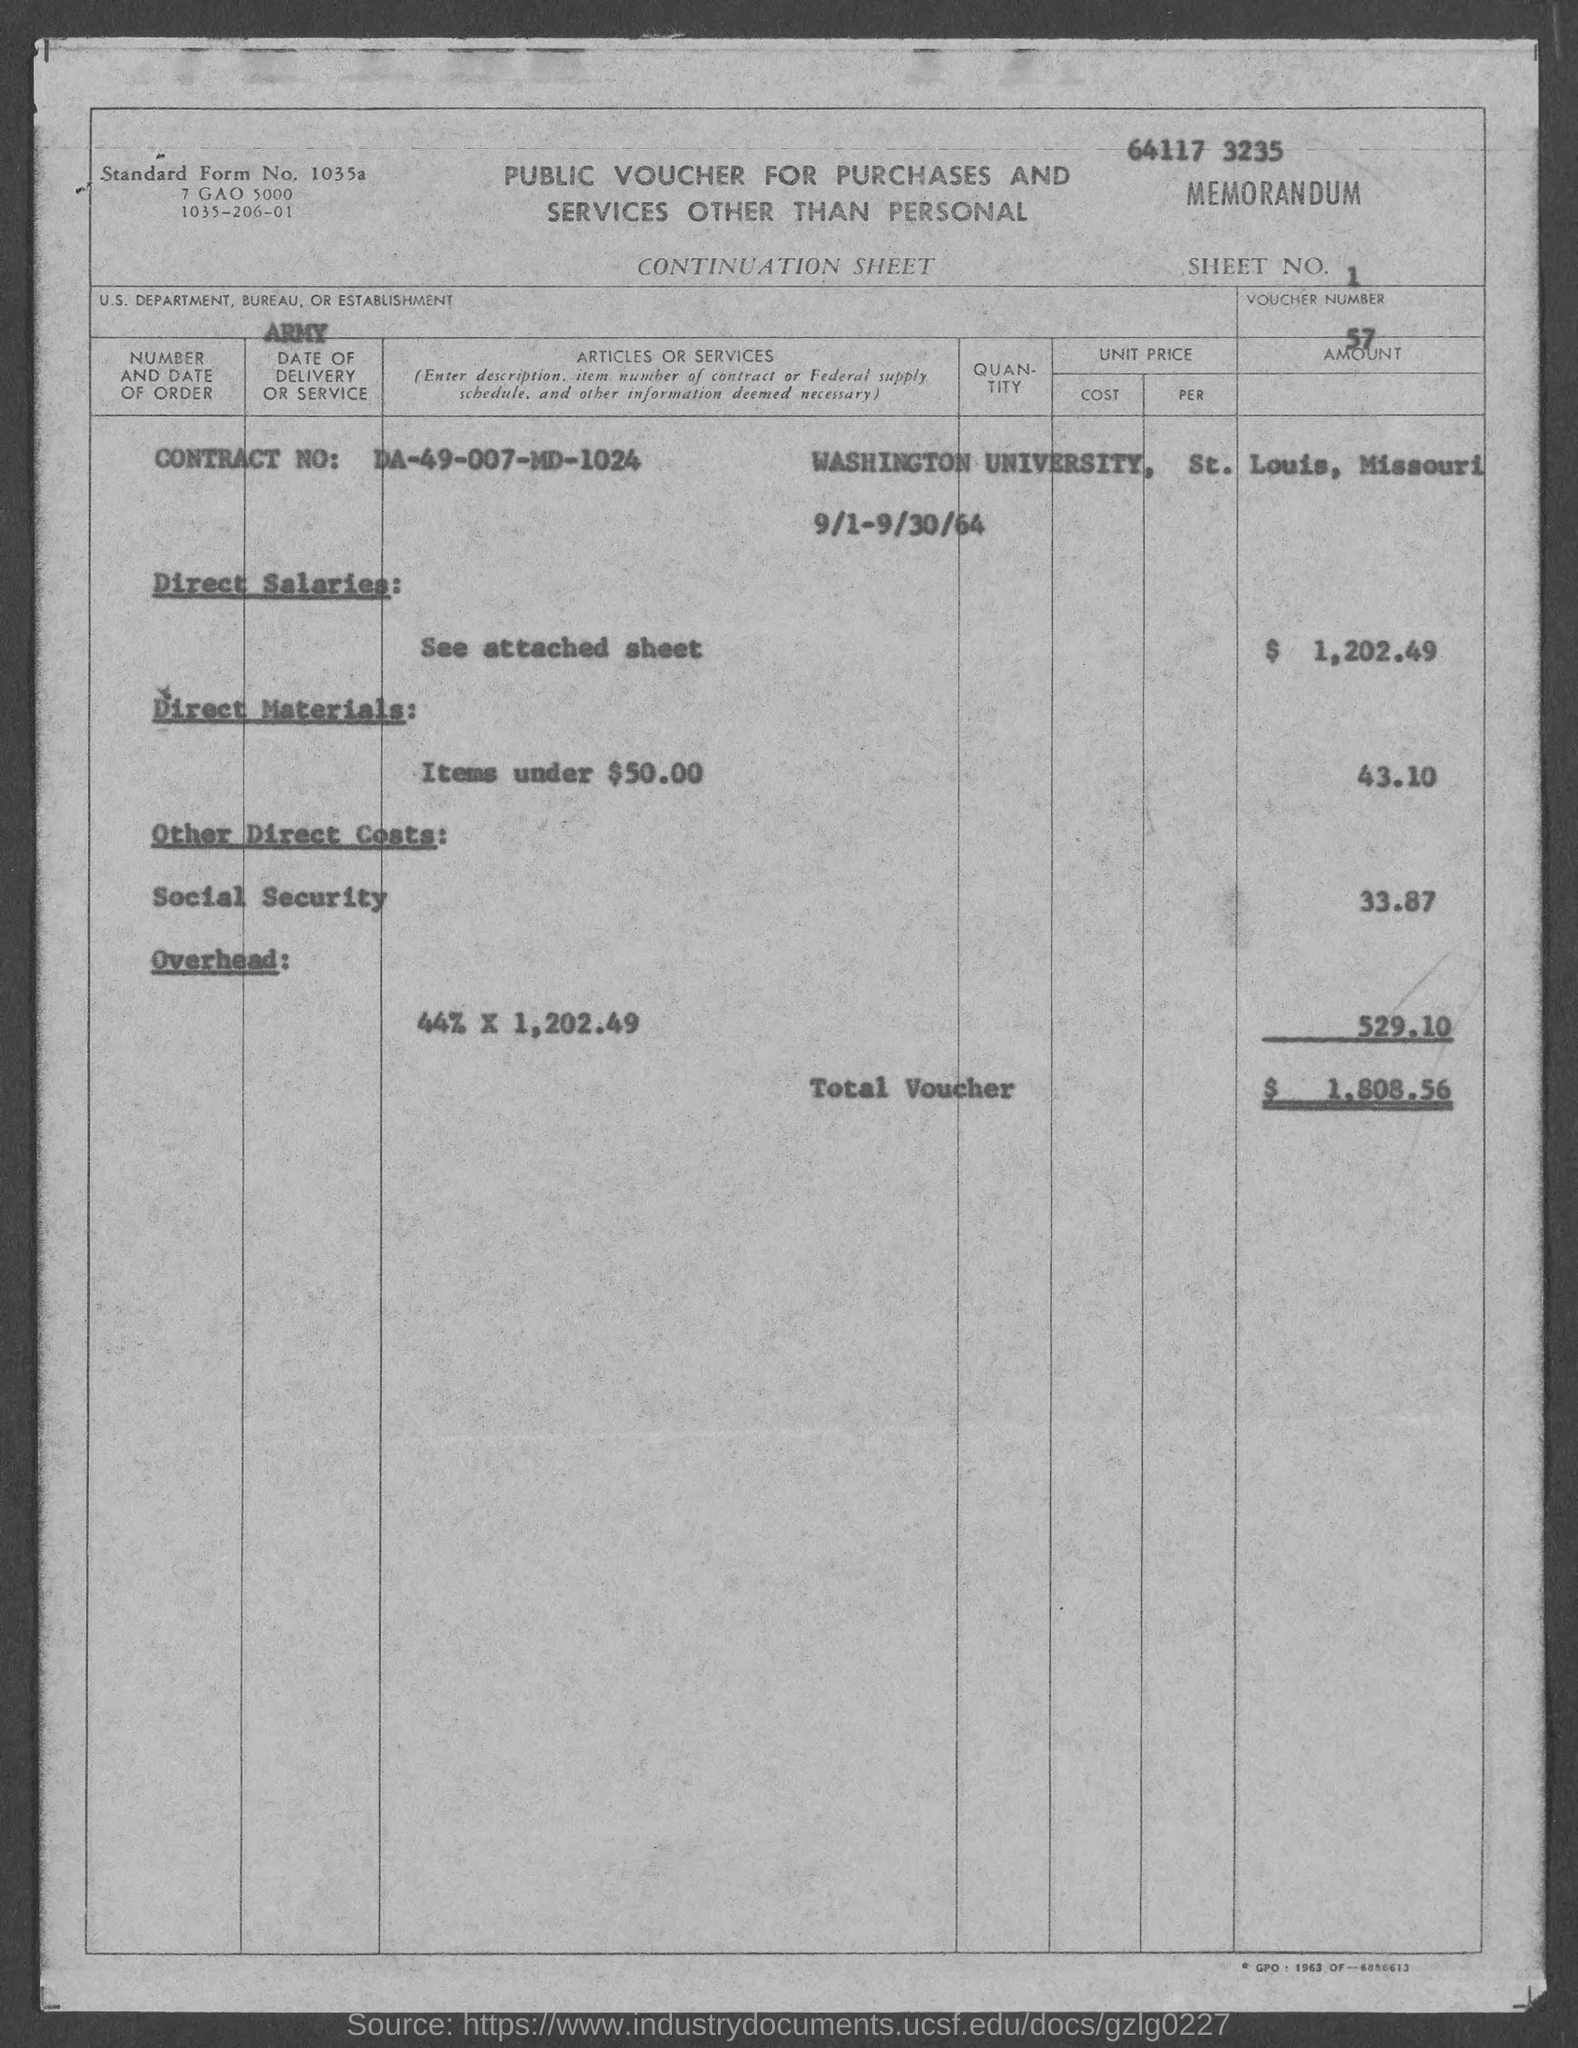Give some essential details in this illustration. The direct salaries amount in the voucher is $1,202.49. What is the US Department, Bureau, or Establishment in voucher related to the army? The contract number is DA-49-007-MD-1024. The total voucher amount is $1,808.56. I am inquiring about the voucher number for order number 57... 